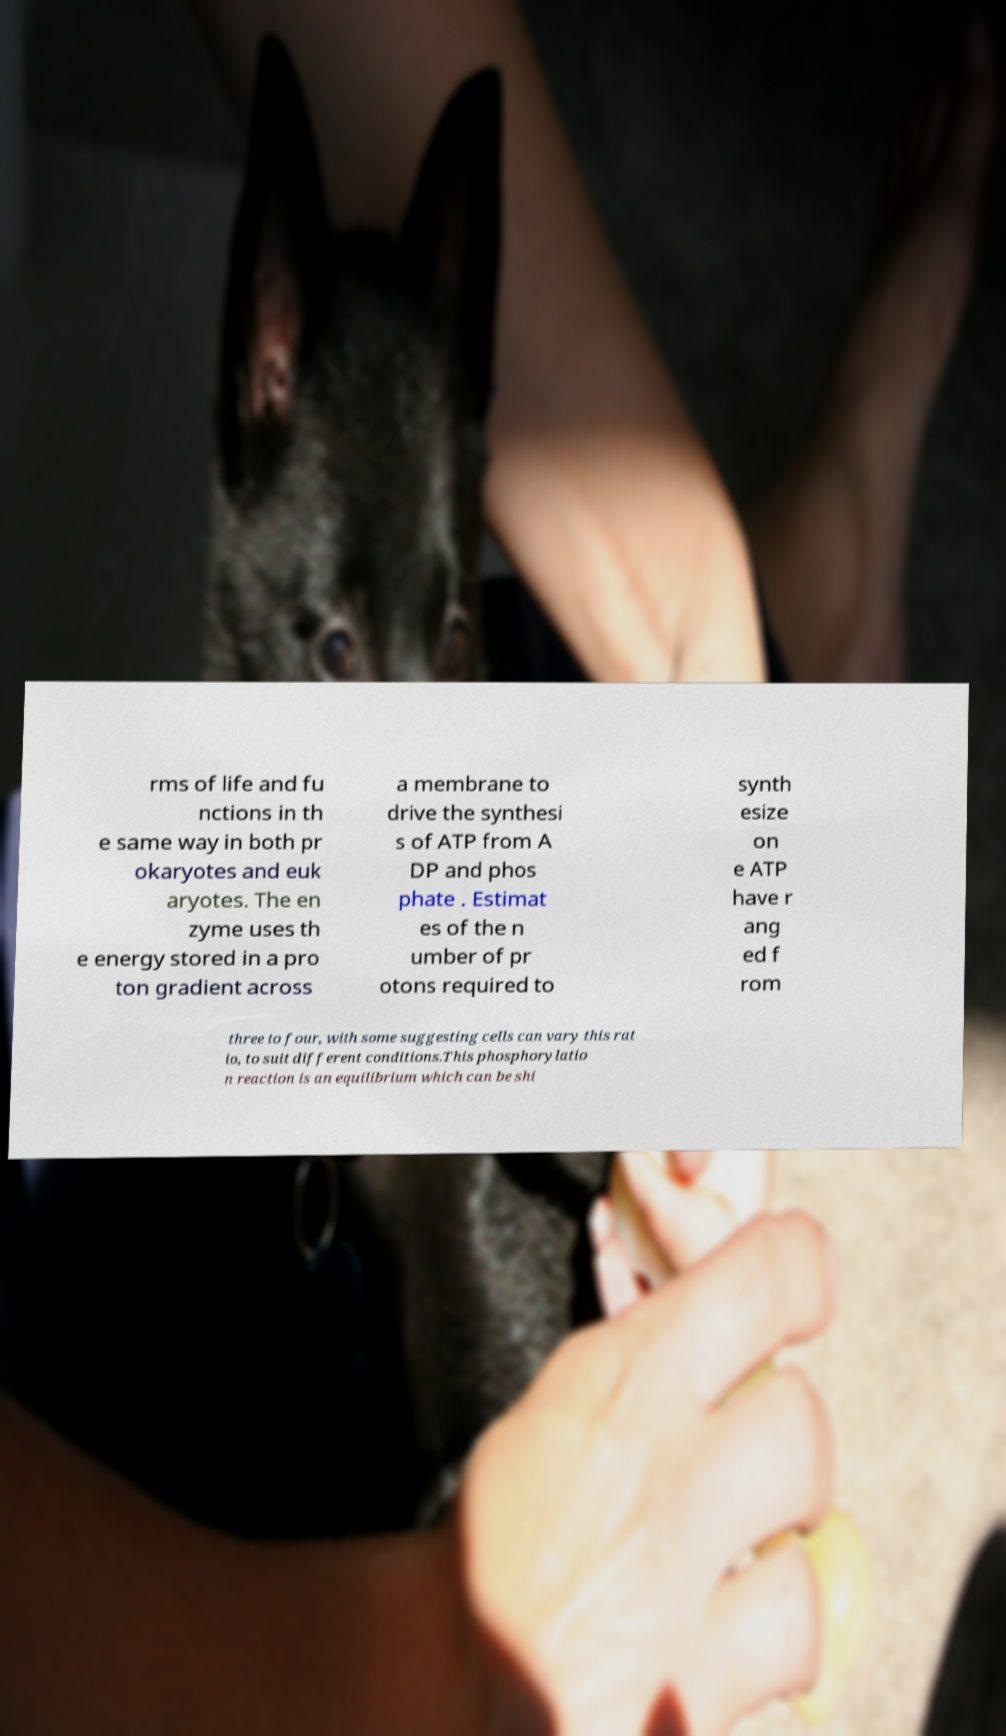What messages or text are displayed in this image? I need them in a readable, typed format. rms of life and fu nctions in th e same way in both pr okaryotes and euk aryotes. The en zyme uses th e energy stored in a pro ton gradient across a membrane to drive the synthesi s of ATP from A DP and phos phate . Estimat es of the n umber of pr otons required to synth esize on e ATP have r ang ed f rom three to four, with some suggesting cells can vary this rat io, to suit different conditions.This phosphorylatio n reaction is an equilibrium which can be shi 